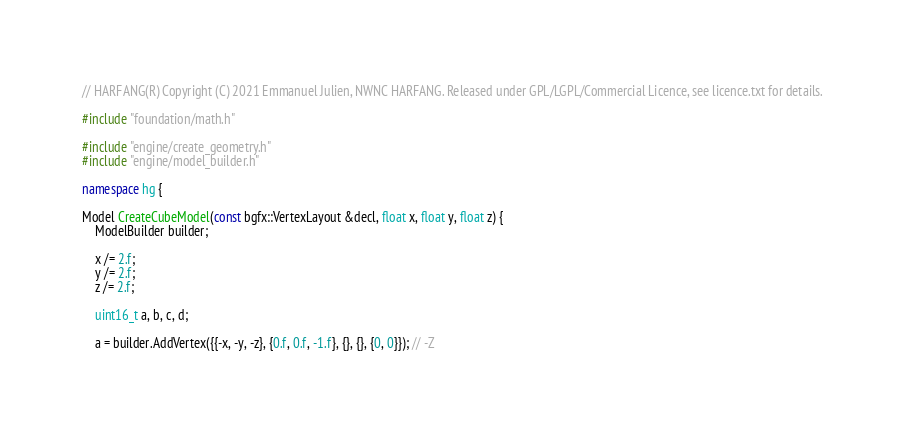<code> <loc_0><loc_0><loc_500><loc_500><_C++_>// HARFANG(R) Copyright (C) 2021 Emmanuel Julien, NWNC HARFANG. Released under GPL/LGPL/Commercial Licence, see licence.txt for details.

#include "foundation/math.h"

#include "engine/create_geometry.h"
#include "engine/model_builder.h"

namespace hg {

Model CreateCubeModel(const bgfx::VertexLayout &decl, float x, float y, float z) {
	ModelBuilder builder;

	x /= 2.f;
	y /= 2.f;
	z /= 2.f;

	uint16_t a, b, c, d;

	a = builder.AddVertex({{-x, -y, -z}, {0.f, 0.f, -1.f}, {}, {}, {0, 0}}); // -Z</code> 